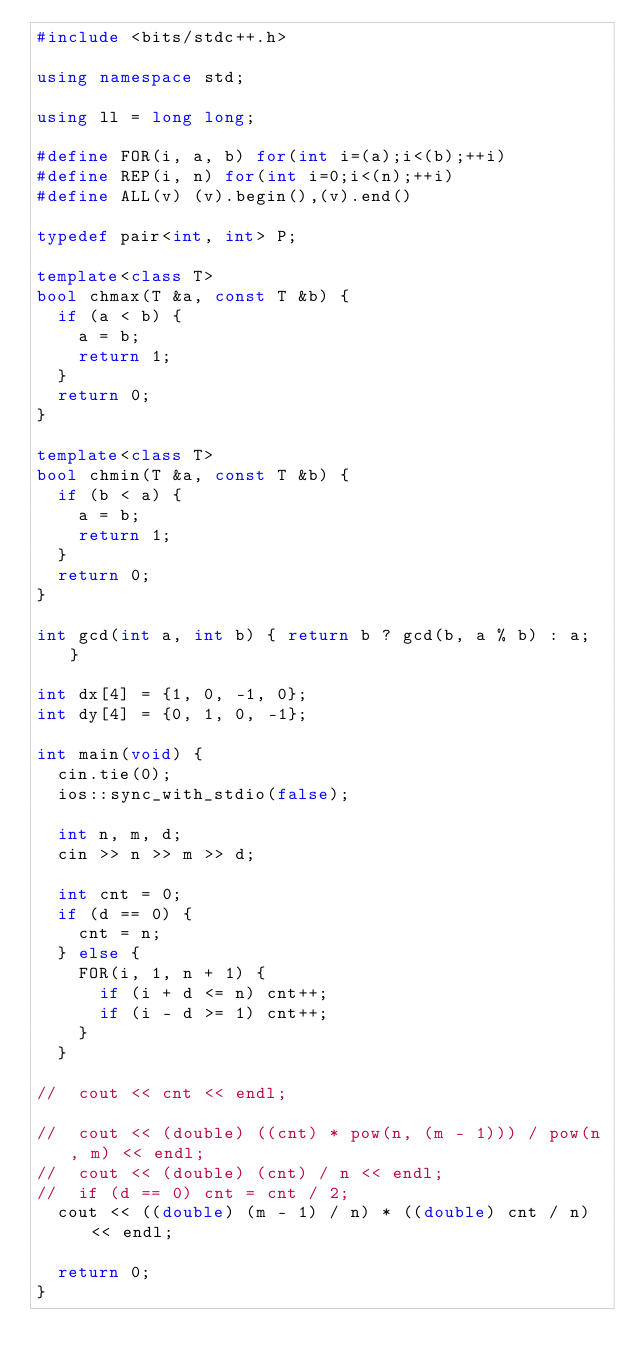<code> <loc_0><loc_0><loc_500><loc_500><_C++_>#include <bits/stdc++.h>

using namespace std;

using ll = long long;

#define FOR(i, a, b) for(int i=(a);i<(b);++i)
#define REP(i, n) for(int i=0;i<(n);++i)
#define ALL(v) (v).begin(),(v).end()

typedef pair<int, int> P;

template<class T>
bool chmax(T &a, const T &b) {
	if (a < b) {
		a = b;
		return 1;
	}
	return 0;
}

template<class T>
bool chmin(T &a, const T &b) {
	if (b < a) {
		a = b;
		return 1;
	}
	return 0;
}

int gcd(int a, int b) { return b ? gcd(b, a % b) : a; }

int dx[4] = {1, 0, -1, 0};
int dy[4] = {0, 1, 0, -1};

int main(void) {
	cin.tie(0);
	ios::sync_with_stdio(false);
	
	int n, m, d;
	cin >> n >> m >> d;
	
	int cnt = 0;
	if (d == 0) {
		cnt = n;
	} else {
		FOR(i, 1, n + 1) {
			if (i + d <= n) cnt++;
			if (i - d >= 1) cnt++;
		}
	}

//	cout << cnt << endl;

//	cout << (double) ((cnt) * pow(n, (m - 1))) / pow(n, m) << endl;
//	cout << (double) (cnt) / n << endl;
//	if (d == 0) cnt = cnt / 2;
	cout << ((double) (m - 1) / n) * ((double) cnt / n) << endl;
	
	return 0;
}</code> 